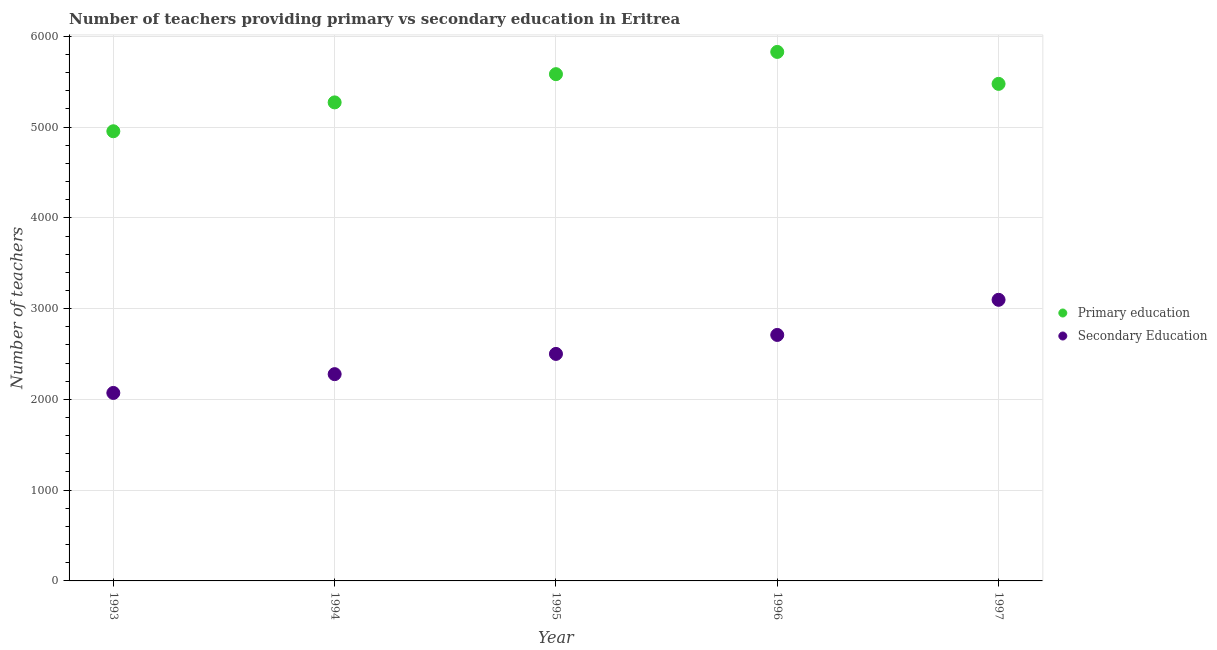How many different coloured dotlines are there?
Ensure brevity in your answer.  2. What is the number of primary teachers in 1995?
Offer a terse response. 5583. Across all years, what is the maximum number of primary teachers?
Your answer should be very brief. 5828. Across all years, what is the minimum number of secondary teachers?
Provide a succinct answer. 2071. In which year was the number of secondary teachers minimum?
Ensure brevity in your answer.  1993. What is the total number of secondary teachers in the graph?
Make the answer very short. 1.27e+04. What is the difference between the number of secondary teachers in 1993 and that in 1997?
Keep it short and to the point. -1026. What is the difference between the number of secondary teachers in 1997 and the number of primary teachers in 1995?
Your response must be concise. -2486. What is the average number of secondary teachers per year?
Your response must be concise. 2531.4. In the year 1996, what is the difference between the number of secondary teachers and number of primary teachers?
Your response must be concise. -3118. In how many years, is the number of secondary teachers greater than 4800?
Provide a short and direct response. 0. What is the ratio of the number of primary teachers in 1993 to that in 1994?
Your answer should be very brief. 0.94. Is the number of primary teachers in 1995 less than that in 1997?
Your response must be concise. No. Is the difference between the number of secondary teachers in 1994 and 1995 greater than the difference between the number of primary teachers in 1994 and 1995?
Your answer should be very brief. Yes. What is the difference between the highest and the second highest number of secondary teachers?
Make the answer very short. 387. What is the difference between the highest and the lowest number of secondary teachers?
Your answer should be very brief. 1026. In how many years, is the number of primary teachers greater than the average number of primary teachers taken over all years?
Your answer should be compact. 3. Does the number of secondary teachers monotonically increase over the years?
Offer a very short reply. Yes. What is the difference between two consecutive major ticks on the Y-axis?
Offer a terse response. 1000. Does the graph contain any zero values?
Keep it short and to the point. No. Does the graph contain grids?
Your answer should be very brief. Yes. How many legend labels are there?
Your answer should be very brief. 2. What is the title of the graph?
Your response must be concise. Number of teachers providing primary vs secondary education in Eritrea. Does "Birth rate" appear as one of the legend labels in the graph?
Offer a terse response. No. What is the label or title of the Y-axis?
Ensure brevity in your answer.  Number of teachers. What is the Number of teachers of Primary education in 1993?
Give a very brief answer. 4954. What is the Number of teachers in Secondary Education in 1993?
Your response must be concise. 2071. What is the Number of teachers in Primary education in 1994?
Ensure brevity in your answer.  5272. What is the Number of teachers in Secondary Education in 1994?
Offer a terse response. 2278. What is the Number of teachers of Primary education in 1995?
Ensure brevity in your answer.  5583. What is the Number of teachers of Secondary Education in 1995?
Your answer should be compact. 2501. What is the Number of teachers of Primary education in 1996?
Offer a terse response. 5828. What is the Number of teachers of Secondary Education in 1996?
Your answer should be compact. 2710. What is the Number of teachers of Primary education in 1997?
Offer a terse response. 5476. What is the Number of teachers in Secondary Education in 1997?
Offer a terse response. 3097. Across all years, what is the maximum Number of teachers in Primary education?
Make the answer very short. 5828. Across all years, what is the maximum Number of teachers in Secondary Education?
Give a very brief answer. 3097. Across all years, what is the minimum Number of teachers in Primary education?
Your answer should be compact. 4954. Across all years, what is the minimum Number of teachers of Secondary Education?
Offer a terse response. 2071. What is the total Number of teachers in Primary education in the graph?
Your answer should be compact. 2.71e+04. What is the total Number of teachers in Secondary Education in the graph?
Provide a short and direct response. 1.27e+04. What is the difference between the Number of teachers in Primary education in 1993 and that in 1994?
Your answer should be compact. -318. What is the difference between the Number of teachers in Secondary Education in 1993 and that in 1994?
Your answer should be very brief. -207. What is the difference between the Number of teachers in Primary education in 1993 and that in 1995?
Make the answer very short. -629. What is the difference between the Number of teachers in Secondary Education in 1993 and that in 1995?
Your answer should be compact. -430. What is the difference between the Number of teachers of Primary education in 1993 and that in 1996?
Make the answer very short. -874. What is the difference between the Number of teachers of Secondary Education in 1993 and that in 1996?
Keep it short and to the point. -639. What is the difference between the Number of teachers in Primary education in 1993 and that in 1997?
Your answer should be compact. -522. What is the difference between the Number of teachers of Secondary Education in 1993 and that in 1997?
Your answer should be compact. -1026. What is the difference between the Number of teachers of Primary education in 1994 and that in 1995?
Provide a succinct answer. -311. What is the difference between the Number of teachers of Secondary Education in 1994 and that in 1995?
Your response must be concise. -223. What is the difference between the Number of teachers of Primary education in 1994 and that in 1996?
Offer a terse response. -556. What is the difference between the Number of teachers of Secondary Education in 1994 and that in 1996?
Ensure brevity in your answer.  -432. What is the difference between the Number of teachers of Primary education in 1994 and that in 1997?
Your response must be concise. -204. What is the difference between the Number of teachers of Secondary Education in 1994 and that in 1997?
Keep it short and to the point. -819. What is the difference between the Number of teachers of Primary education in 1995 and that in 1996?
Provide a succinct answer. -245. What is the difference between the Number of teachers of Secondary Education in 1995 and that in 1996?
Offer a terse response. -209. What is the difference between the Number of teachers in Primary education in 1995 and that in 1997?
Provide a succinct answer. 107. What is the difference between the Number of teachers of Secondary Education in 1995 and that in 1997?
Offer a very short reply. -596. What is the difference between the Number of teachers of Primary education in 1996 and that in 1997?
Your response must be concise. 352. What is the difference between the Number of teachers of Secondary Education in 1996 and that in 1997?
Give a very brief answer. -387. What is the difference between the Number of teachers of Primary education in 1993 and the Number of teachers of Secondary Education in 1994?
Make the answer very short. 2676. What is the difference between the Number of teachers in Primary education in 1993 and the Number of teachers in Secondary Education in 1995?
Keep it short and to the point. 2453. What is the difference between the Number of teachers in Primary education in 1993 and the Number of teachers in Secondary Education in 1996?
Your answer should be compact. 2244. What is the difference between the Number of teachers of Primary education in 1993 and the Number of teachers of Secondary Education in 1997?
Your response must be concise. 1857. What is the difference between the Number of teachers of Primary education in 1994 and the Number of teachers of Secondary Education in 1995?
Make the answer very short. 2771. What is the difference between the Number of teachers of Primary education in 1994 and the Number of teachers of Secondary Education in 1996?
Keep it short and to the point. 2562. What is the difference between the Number of teachers of Primary education in 1994 and the Number of teachers of Secondary Education in 1997?
Provide a short and direct response. 2175. What is the difference between the Number of teachers in Primary education in 1995 and the Number of teachers in Secondary Education in 1996?
Ensure brevity in your answer.  2873. What is the difference between the Number of teachers in Primary education in 1995 and the Number of teachers in Secondary Education in 1997?
Your answer should be compact. 2486. What is the difference between the Number of teachers in Primary education in 1996 and the Number of teachers in Secondary Education in 1997?
Give a very brief answer. 2731. What is the average Number of teachers in Primary education per year?
Keep it short and to the point. 5422.6. What is the average Number of teachers of Secondary Education per year?
Make the answer very short. 2531.4. In the year 1993, what is the difference between the Number of teachers in Primary education and Number of teachers in Secondary Education?
Offer a terse response. 2883. In the year 1994, what is the difference between the Number of teachers in Primary education and Number of teachers in Secondary Education?
Provide a short and direct response. 2994. In the year 1995, what is the difference between the Number of teachers in Primary education and Number of teachers in Secondary Education?
Give a very brief answer. 3082. In the year 1996, what is the difference between the Number of teachers in Primary education and Number of teachers in Secondary Education?
Your answer should be very brief. 3118. In the year 1997, what is the difference between the Number of teachers of Primary education and Number of teachers of Secondary Education?
Give a very brief answer. 2379. What is the ratio of the Number of teachers of Primary education in 1993 to that in 1994?
Offer a very short reply. 0.94. What is the ratio of the Number of teachers of Secondary Education in 1993 to that in 1994?
Ensure brevity in your answer.  0.91. What is the ratio of the Number of teachers of Primary education in 1993 to that in 1995?
Provide a succinct answer. 0.89. What is the ratio of the Number of teachers of Secondary Education in 1993 to that in 1995?
Offer a terse response. 0.83. What is the ratio of the Number of teachers in Secondary Education in 1993 to that in 1996?
Your answer should be compact. 0.76. What is the ratio of the Number of teachers of Primary education in 1993 to that in 1997?
Your answer should be compact. 0.9. What is the ratio of the Number of teachers in Secondary Education in 1993 to that in 1997?
Provide a short and direct response. 0.67. What is the ratio of the Number of teachers of Primary education in 1994 to that in 1995?
Provide a succinct answer. 0.94. What is the ratio of the Number of teachers in Secondary Education in 1994 to that in 1995?
Give a very brief answer. 0.91. What is the ratio of the Number of teachers of Primary education in 1994 to that in 1996?
Give a very brief answer. 0.9. What is the ratio of the Number of teachers of Secondary Education in 1994 to that in 1996?
Your response must be concise. 0.84. What is the ratio of the Number of teachers of Primary education in 1994 to that in 1997?
Ensure brevity in your answer.  0.96. What is the ratio of the Number of teachers in Secondary Education in 1994 to that in 1997?
Offer a very short reply. 0.74. What is the ratio of the Number of teachers in Primary education in 1995 to that in 1996?
Provide a succinct answer. 0.96. What is the ratio of the Number of teachers of Secondary Education in 1995 to that in 1996?
Provide a succinct answer. 0.92. What is the ratio of the Number of teachers in Primary education in 1995 to that in 1997?
Your answer should be very brief. 1.02. What is the ratio of the Number of teachers of Secondary Education in 1995 to that in 1997?
Your response must be concise. 0.81. What is the ratio of the Number of teachers of Primary education in 1996 to that in 1997?
Your answer should be compact. 1.06. What is the ratio of the Number of teachers in Secondary Education in 1996 to that in 1997?
Your answer should be very brief. 0.88. What is the difference between the highest and the second highest Number of teachers in Primary education?
Offer a terse response. 245. What is the difference between the highest and the second highest Number of teachers of Secondary Education?
Give a very brief answer. 387. What is the difference between the highest and the lowest Number of teachers of Primary education?
Your answer should be very brief. 874. What is the difference between the highest and the lowest Number of teachers in Secondary Education?
Offer a terse response. 1026. 